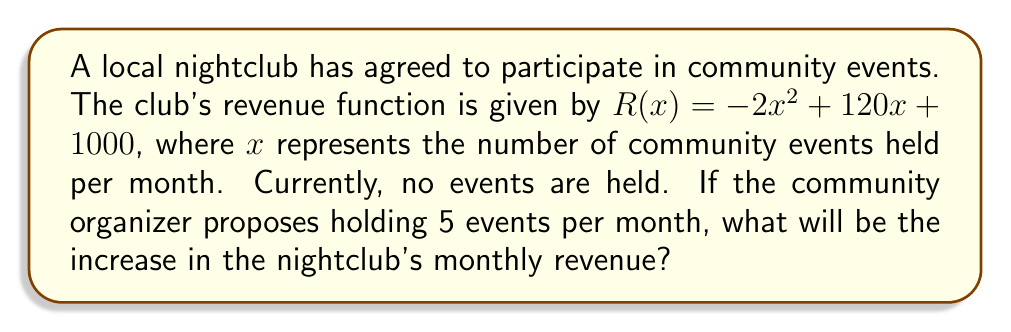Show me your answer to this math problem. Let's approach this step-by-step:

1) The revenue function is given by $R(x) = -2x^2 + 120x + 1000$

2) Currently, no events are held, so $x = 0$
   Revenue with no events: $R(0) = -2(0)^2 + 120(0) + 1000 = 1000$

3) The proposal is to hold 5 events per month, so $x = 5$
   Revenue with 5 events: $R(5) = -2(5)^2 + 120(5) + 1000$
                                 $= -50 + 600 + 1000 = 1550$

4) To find the increase in revenue, we subtract the initial revenue from the new revenue:
   Increase = $R(5) - R(0) = 1550 - 1000 = 550$

Therefore, the increase in the nightclub's monthly revenue will be $550.
Answer: $550 